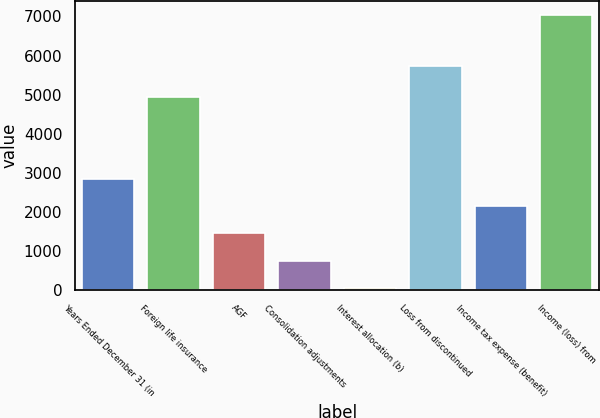Convert chart to OTSL. <chart><loc_0><loc_0><loc_500><loc_500><bar_chart><fcel>Years Ended December 31 (in<fcel>Foreign life insurance<fcel>AGF<fcel>Consolidation adjustments<fcel>Interest allocation (b)<fcel>Loss from discontinued<fcel>Income tax expense (benefit)<fcel>Income (loss) from<nl><fcel>2849.4<fcel>4941<fcel>1452.2<fcel>753.6<fcel>55<fcel>5732<fcel>2150.8<fcel>7041<nl></chart> 